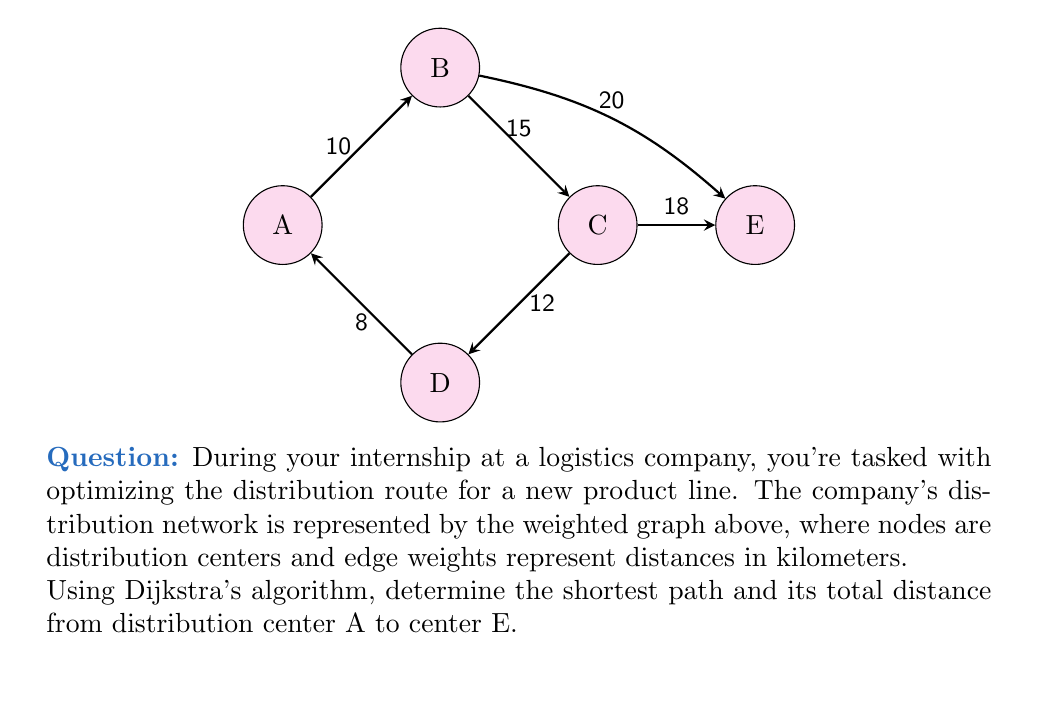What is the answer to this math problem? To solve this problem using Dijkstra's algorithm, we'll follow these steps:

1) Initialize:
   - Set distance to A as 0, and all other nodes as infinity.
   - Set all nodes as unvisited.
   - Set A as the current node.

2) For the current node, consider all unvisited neighbors and calculate their tentative distances.
   - If the calculated distance is less than the previously recorded distance, update it.

3) Mark the current node as visited and remove it from the unvisited set.

4) If the destination node (E) has been marked visited, we're done.
   Otherwise, select the unvisited node with the smallest tentative distance and set it as the new current node. Go back to step 2.

Let's apply the algorithm:

1) Start at A: 
   A(0), B(∞), C(∞), D(∞), E(∞)

2) Consider A's neighbors:
   Update B: A to B = 10
   Update D: A to D = 8
   A(0), B(10), C(∞), D(8), E(∞)

3) Mark A as visited. D has the smallest tentative distance, so it becomes the current node.

4) Consider D's neighbors:
   A is already visited.
   Update C: A to D to C = 8 + 12 = 20
   A(0), B(10), C(20), D(8), E(∞)

5) Mark D as visited. B has the smallest tentative distance, so it becomes the current node.

6) Consider B's neighbors:
   A and D are already visited.
   Update C: A to B to C = 10 + 15 = 25 (not smaller than current C, so no update)
   Update E: A to B to E = 10 + 20 = 30
   A(0), B(10), C(20), D(8), E(30)

7) Mark B as visited. C has the smallest tentative distance, so it becomes the current node.

8) Consider C's neighbors:
   B and D are already visited.
   Update E: A to D to C to E = 8 + 12 + 18 = 38 (not smaller than current E, so no update)

9) Mark C as visited. E is the only unvisited node left, so it becomes the current node.

10) E has no unvisited neighbors, so we're done.

The shortest path is A → B → E with a total distance of 30 km.
Answer: A → B → E, 30 km 